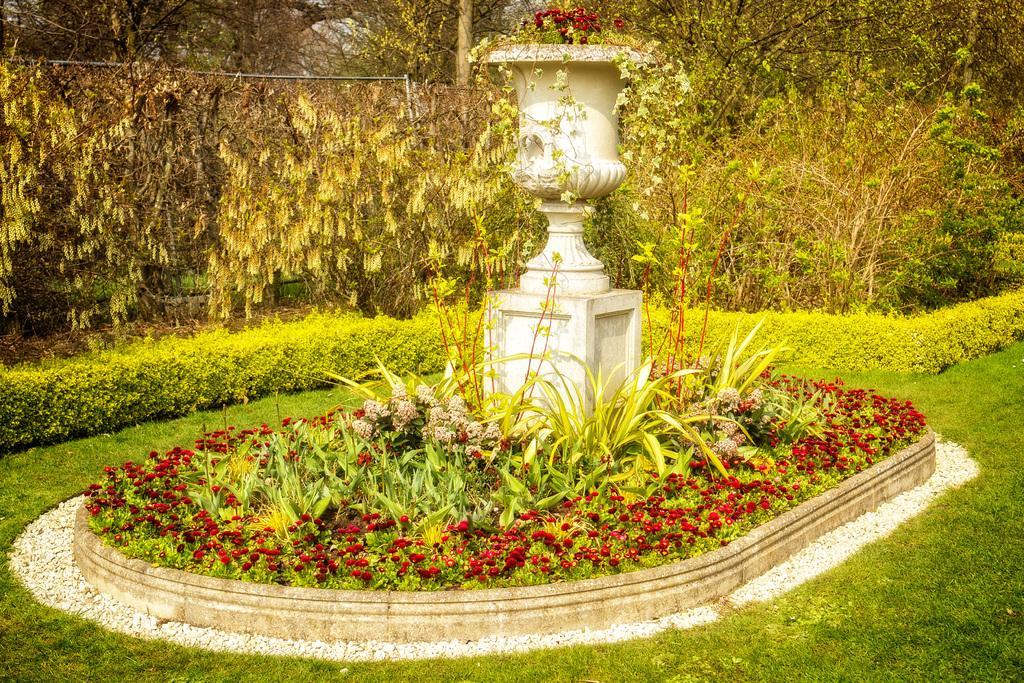Describe this image in one or two sentences. In this picture there is a fountain which has few flowers which are in red color around it and there are few plants and trees in the background. 